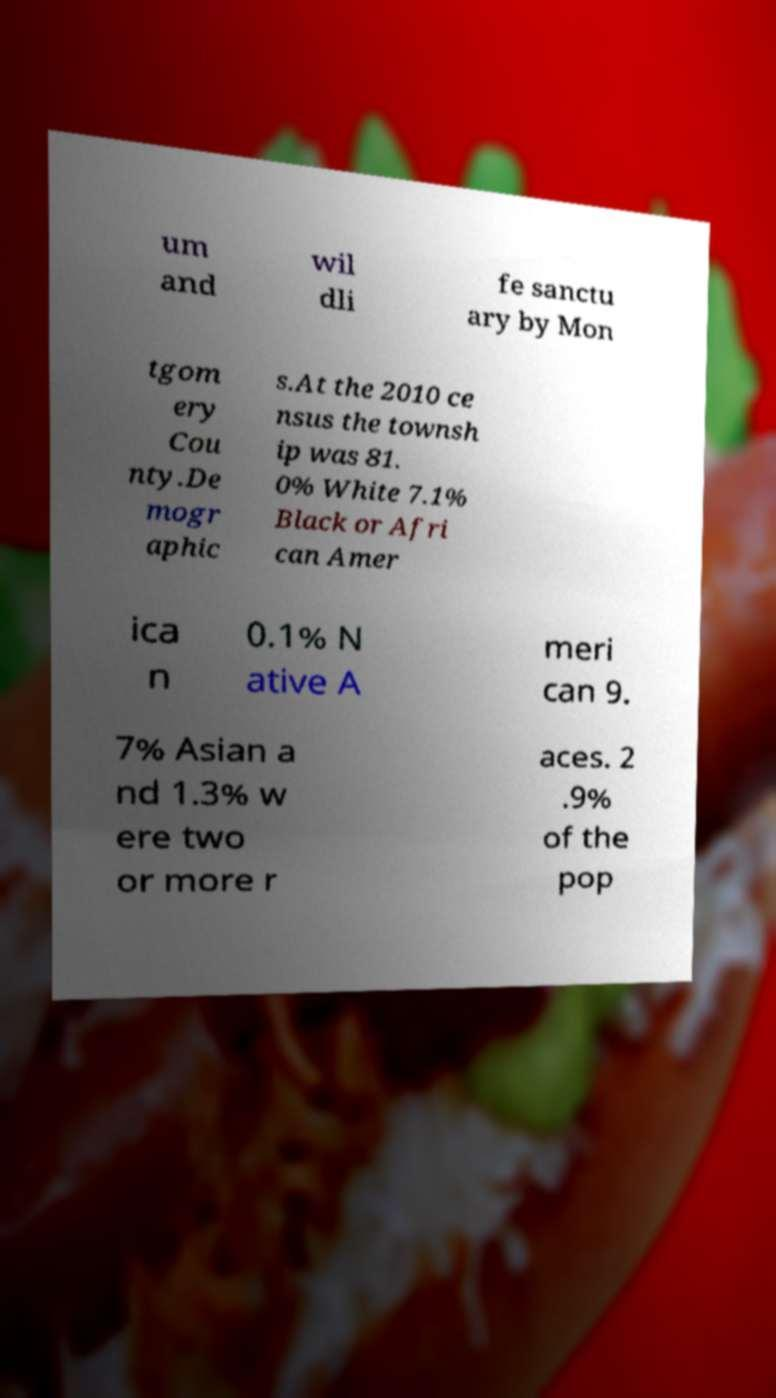There's text embedded in this image that I need extracted. Can you transcribe it verbatim? um and wil dli fe sanctu ary by Mon tgom ery Cou nty.De mogr aphic s.At the 2010 ce nsus the townsh ip was 81. 0% White 7.1% Black or Afri can Amer ica n 0.1% N ative A meri can 9. 7% Asian a nd 1.3% w ere two or more r aces. 2 .9% of the pop 